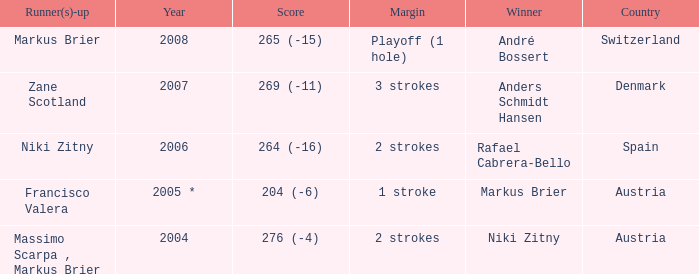In what year was the score 204 (-6)? 2005 *. 